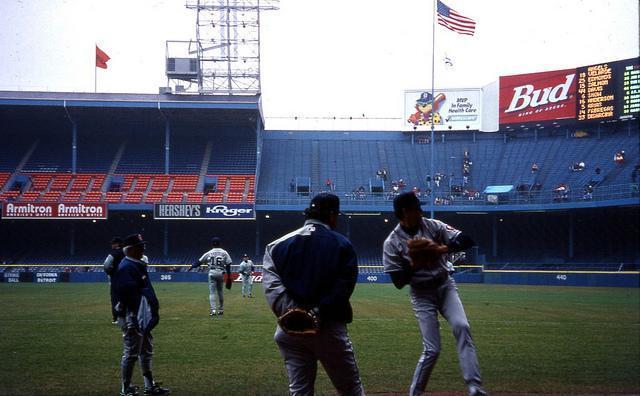How many stars in the Budweiser sign?
Give a very brief answer. 0. How many people are there?
Give a very brief answer. 3. How many cars are in the road?
Give a very brief answer. 0. 